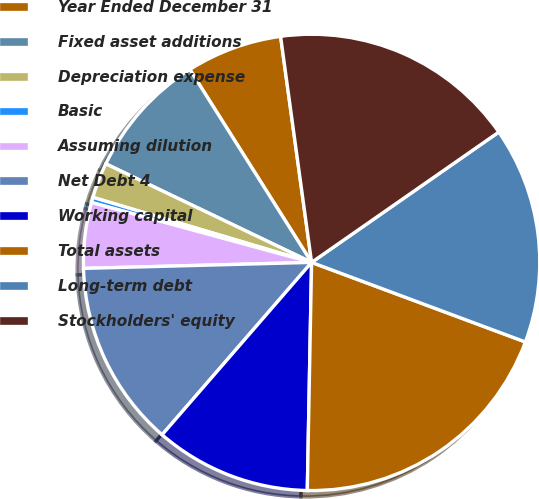Convert chart to OTSL. <chart><loc_0><loc_0><loc_500><loc_500><pie_chart><fcel>Year Ended December 31<fcel>Fixed asset additions<fcel>Depreciation expense<fcel>Basic<fcel>Assuming dilution<fcel>Net Debt 4<fcel>Working capital<fcel>Total assets<fcel>Long-term debt<fcel>Stockholders' equity<nl><fcel>6.79%<fcel>8.93%<fcel>2.51%<fcel>0.37%<fcel>4.65%<fcel>13.21%<fcel>11.07%<fcel>19.63%<fcel>15.35%<fcel>17.49%<nl></chart> 